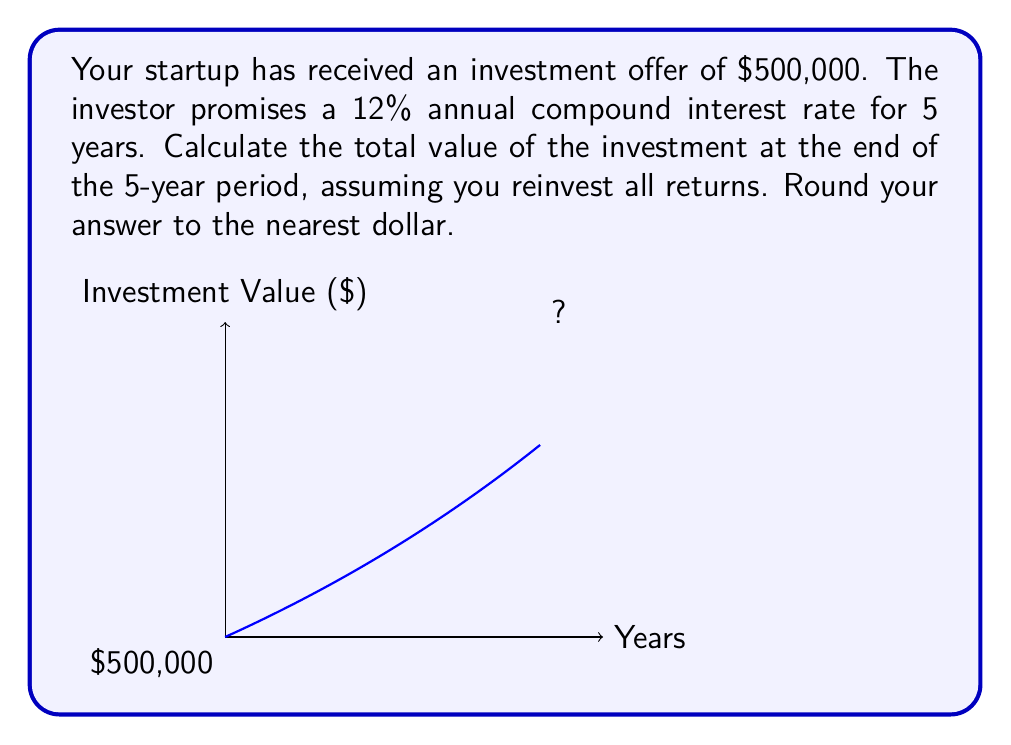Can you answer this question? To solve this problem, we'll use the compound interest formula:

$$A = P(1 + r)^n$$

Where:
$A$ = final amount
$P$ = principal (initial investment)
$r$ = annual interest rate (in decimal form)
$n$ = number of years

Given:
$P = \$500,000$
$r = 12\% = 0.12$
$n = 5$ years

Let's plug these values into the formula:

$$A = 500,000(1 + 0.12)^5$$

Now, let's calculate step-by-step:

1) First, calculate $(1 + 0.12)^5$:
   $(1.12)^5 = 1.762341$

2) Multiply this by the principal:
   $500,000 \times 1.762341 = 881,170.50$

3) Round to the nearest dollar:
   $881,171$

Therefore, the total value of the investment after 5 years would be $881,171.
Answer: $881,171 